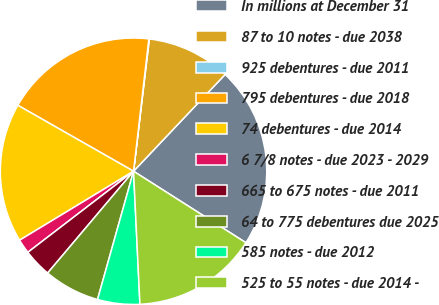Convert chart. <chart><loc_0><loc_0><loc_500><loc_500><pie_chart><fcel>In millions at December 31<fcel>87 to 10 notes - due 2038<fcel>925 debentures - due 2011<fcel>795 debentures - due 2018<fcel>74 debentures - due 2014<fcel>6 7/8 notes - due 2023 - 2029<fcel>665 to 675 notes - due 2011<fcel>64 to 775 debentures due 2025<fcel>585 notes - due 2012<fcel>525 to 55 notes - due 2014 -<nl><fcel>21.96%<fcel>10.17%<fcel>0.06%<fcel>18.59%<fcel>16.91%<fcel>1.75%<fcel>3.43%<fcel>6.8%<fcel>5.12%<fcel>15.22%<nl></chart> 